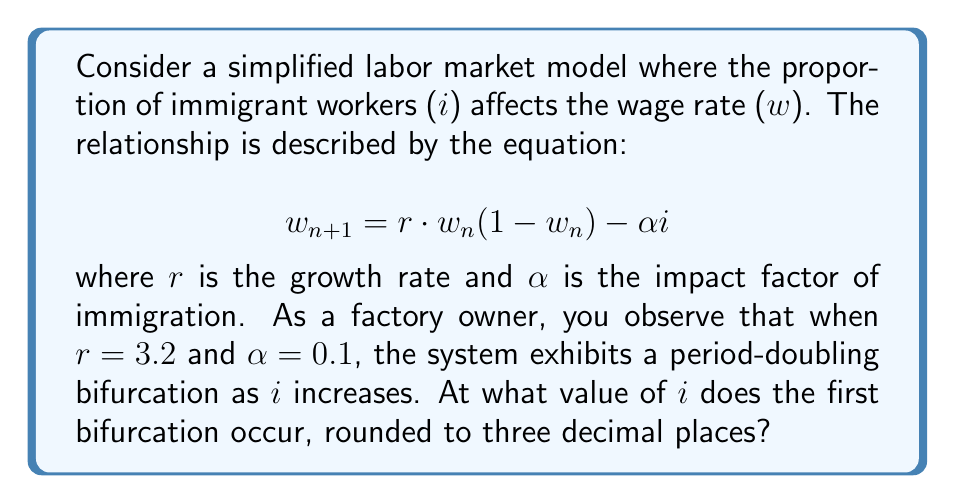Help me with this question. To find the first bifurcation point, we need to follow these steps:

1) The bifurcation occurs when the stability of the fixed point changes. This happens when the absolute value of the derivative of the function at the fixed point equals 1.

2) Let's call our function $f(w) = r \cdot w(1-w) - \alpha i$

3) The derivative of this function is:
   $$f'(w) = r(1-2w)$$

4) The fixed point $w^*$ satisfies:
   $$w^* = r \cdot w^*(1-w^*) - \alpha i$$

5) Solving this equation:
   $$w^* = \frac{r-1-\sqrt{(r-1)^2-4r\alpha i}}{2r}$$

6) At the bifurcation point, $|f'(w^*)| = 1$. Let's consider the case where $f'(w^*) = -1$ (as $r > 2$):

   $$r(1-2w^*) = -1$$

7) Solving this:
   $$w^* = \frac{r+1}{2r}$$

8) Substituting this back into the fixed point equation:

   $$\frac{r+1}{2r} = r \cdot \frac{r+1}{2r}(1-\frac{r+1}{2r}) - \alpha i$$

9) Simplifying and solving for $i$:

   $$i = \frac{(r+1)(3-r)}{4r\alpha}$$

10) Plugging in the given values $r=3.2$ and $\alpha=0.1$:

    $$i = \frac{(3.2+1)(3-3.2)}{4(3.2)(0.1)} = 0.15625$$

11) Rounding to three decimal places: 0.156
Answer: 0.156 